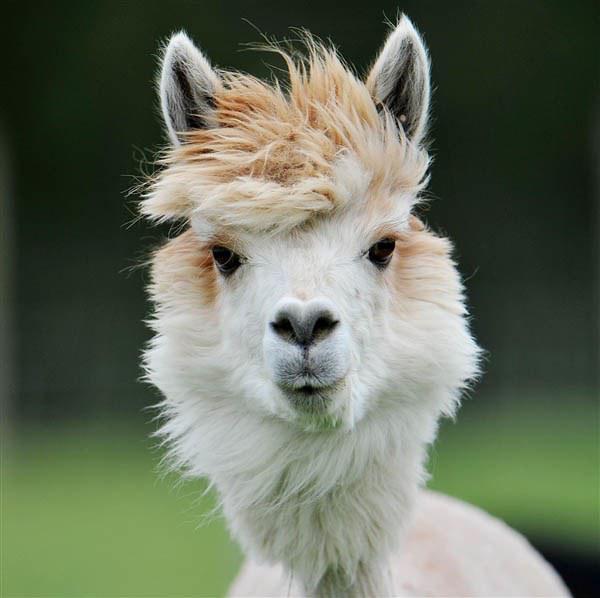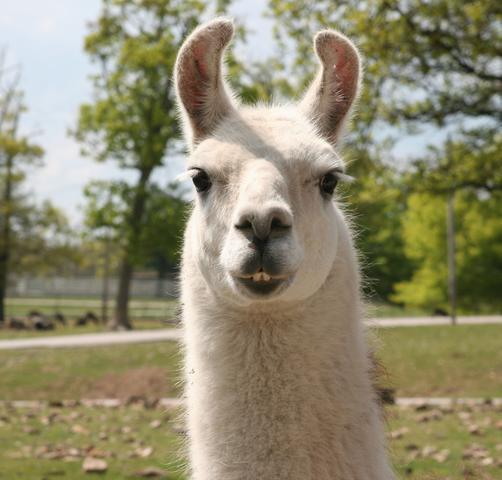The first image is the image on the left, the second image is the image on the right. Evaluate the accuracy of this statement regarding the images: "Each image features one llama in the foreground, and the righthand llama looks at the camera with a toothy smile.". Is it true? Answer yes or no. Yes. The first image is the image on the left, the second image is the image on the right. Analyze the images presented: Is the assertion "In the image on the right, the llama's eyes are obscured." valid? Answer yes or no. No. 